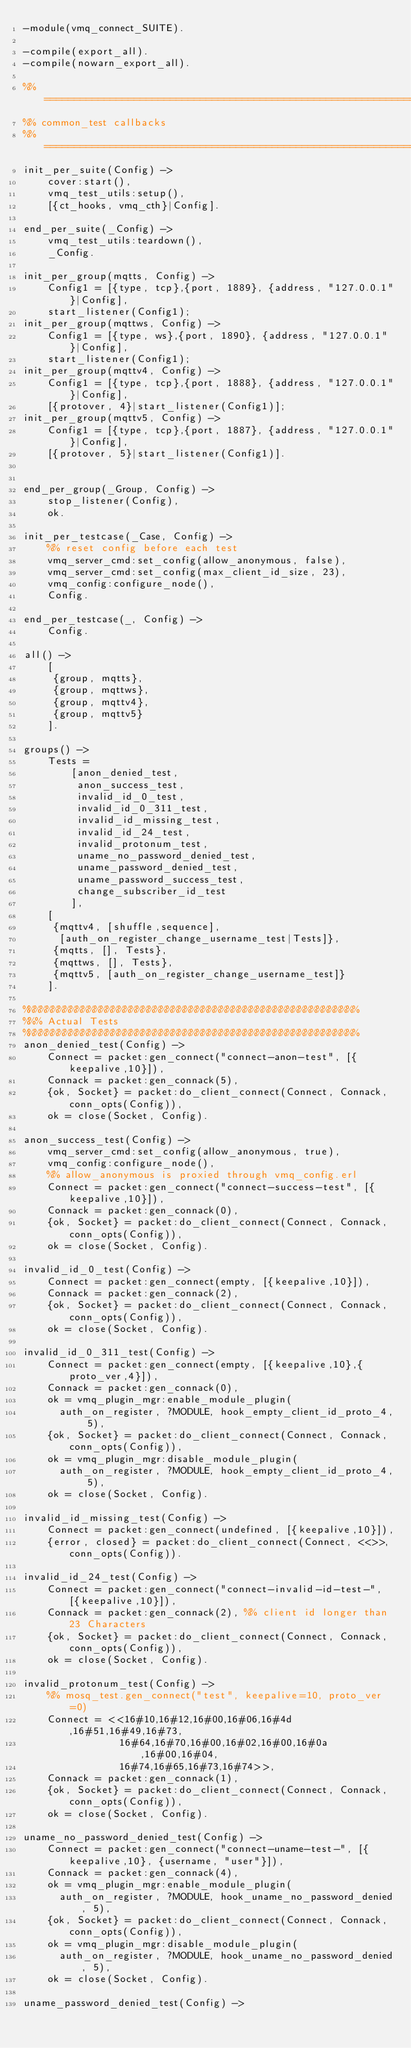<code> <loc_0><loc_0><loc_500><loc_500><_Erlang_>-module(vmq_connect_SUITE).

-compile(export_all).
-compile(nowarn_export_all).

%% ===================================================================
%% common_test callbacks
%% ===================================================================
init_per_suite(Config) ->
    cover:start(),
    vmq_test_utils:setup(),
    [{ct_hooks, vmq_cth}|Config].

end_per_suite(_Config) ->
    vmq_test_utils:teardown(),
    _Config.

init_per_group(mqtts, Config) ->
    Config1 = [{type, tcp},{port, 1889}, {address, "127.0.0.1"}|Config],
    start_listener(Config1);
init_per_group(mqttws, Config) ->
    Config1 = [{type, ws},{port, 1890}, {address, "127.0.0.1"}|Config],
    start_listener(Config1);
init_per_group(mqttv4, Config) ->
    Config1 = [{type, tcp},{port, 1888}, {address, "127.0.0.1"}|Config],
    [{protover, 4}|start_listener(Config1)];
init_per_group(mqttv5, Config) ->
    Config1 = [{type, tcp},{port, 1887}, {address, "127.0.0.1"}|Config],
    [{protover, 5}|start_listener(Config1)].


end_per_group(_Group, Config) ->
    stop_listener(Config),
    ok.

init_per_testcase(_Case, Config) ->
    %% reset config before each test
    vmq_server_cmd:set_config(allow_anonymous, false),
    vmq_server_cmd:set_config(max_client_id_size, 23),
    vmq_config:configure_node(),
    Config.

end_per_testcase(_, Config) ->
    Config.

all() ->
    [
     {group, mqtts},
     {group, mqttws},
     {group, mqttv4},
     {group, mqttv5}
    ].

groups() ->
    Tests = 
        [anon_denied_test,
         anon_success_test,
         invalid_id_0_test,
         invalid_id_0_311_test,
         invalid_id_missing_test,
         invalid_id_24_test,
         invalid_protonum_test,
         uname_no_password_denied_test,
         uname_password_denied_test,
         uname_password_success_test,
         change_subscriber_id_test
        ],
    [
     {mqttv4, [shuffle,sequence],
      [auth_on_register_change_username_test|Tests]},
     {mqtts, [], Tests},
     {mqttws, [], Tests},
     {mqttv5, [auth_on_register_change_username_test]}
    ].

%%%%%%%%%%%%%%%%%%%%%%%%%%%%%%%%%%%%%%%%%%%%%%%%%%%%%%%%
%%% Actual Tests
%%%%%%%%%%%%%%%%%%%%%%%%%%%%%%%%%%%%%%%%%%%%%%%%%%%%%%%%
anon_denied_test(Config) ->
    Connect = packet:gen_connect("connect-anon-test", [{keepalive,10}]),
    Connack = packet:gen_connack(5),
    {ok, Socket} = packet:do_client_connect(Connect, Connack, conn_opts(Config)),
    ok = close(Socket, Config).

anon_success_test(Config) ->
    vmq_server_cmd:set_config(allow_anonymous, true),
    vmq_config:configure_node(),
    %% allow_anonymous is proxied through vmq_config.erl
    Connect = packet:gen_connect("connect-success-test", [{keepalive,10}]),
    Connack = packet:gen_connack(0),
    {ok, Socket} = packet:do_client_connect(Connect, Connack, conn_opts(Config)),
    ok = close(Socket, Config).

invalid_id_0_test(Config) ->
    Connect = packet:gen_connect(empty, [{keepalive,10}]),
    Connack = packet:gen_connack(2),
    {ok, Socket} = packet:do_client_connect(Connect, Connack, conn_opts(Config)),
    ok = close(Socket, Config).

invalid_id_0_311_test(Config) ->
    Connect = packet:gen_connect(empty, [{keepalive,10},{proto_ver,4}]),
    Connack = packet:gen_connack(0),
    ok = vmq_plugin_mgr:enable_module_plugin(
      auth_on_register, ?MODULE, hook_empty_client_id_proto_4, 5),
    {ok, Socket} = packet:do_client_connect(Connect, Connack, conn_opts(Config)),
    ok = vmq_plugin_mgr:disable_module_plugin(
      auth_on_register, ?MODULE, hook_empty_client_id_proto_4, 5),
    ok = close(Socket, Config).

invalid_id_missing_test(Config) ->
    Connect = packet:gen_connect(undefined, [{keepalive,10}]),
    {error, closed} = packet:do_client_connect(Connect, <<>>, conn_opts(Config)).

invalid_id_24_test(Config) ->
    Connect = packet:gen_connect("connect-invalid-id-test-", [{keepalive,10}]),
    Connack = packet:gen_connack(2), %% client id longer than 23 Characters
    {ok, Socket} = packet:do_client_connect(Connect, Connack, conn_opts(Config)),
    ok = close(Socket, Config).

invalid_protonum_test(Config) ->
    %% mosq_test.gen_connect("test", keepalive=10, proto_ver=0)
    Connect = <<16#10,16#12,16#00,16#06,16#4d,16#51,16#49,16#73,
                16#64,16#70,16#00,16#02,16#00,16#0a,16#00,16#04,
                16#74,16#65,16#73,16#74>>,
    Connack = packet:gen_connack(1),
    {ok, Socket} = packet:do_client_connect(Connect, Connack, conn_opts(Config)),
    ok = close(Socket, Config).

uname_no_password_denied_test(Config) ->
    Connect = packet:gen_connect("connect-uname-test-", [{keepalive,10}, {username, "user"}]),
    Connack = packet:gen_connack(4),
    ok = vmq_plugin_mgr:enable_module_plugin(
      auth_on_register, ?MODULE, hook_uname_no_password_denied, 5),
    {ok, Socket} = packet:do_client_connect(Connect, Connack, conn_opts(Config)),
    ok = vmq_plugin_mgr:disable_module_plugin(
      auth_on_register, ?MODULE, hook_uname_no_password_denied, 5),
    ok = close(Socket, Config).

uname_password_denied_test(Config) -></code> 